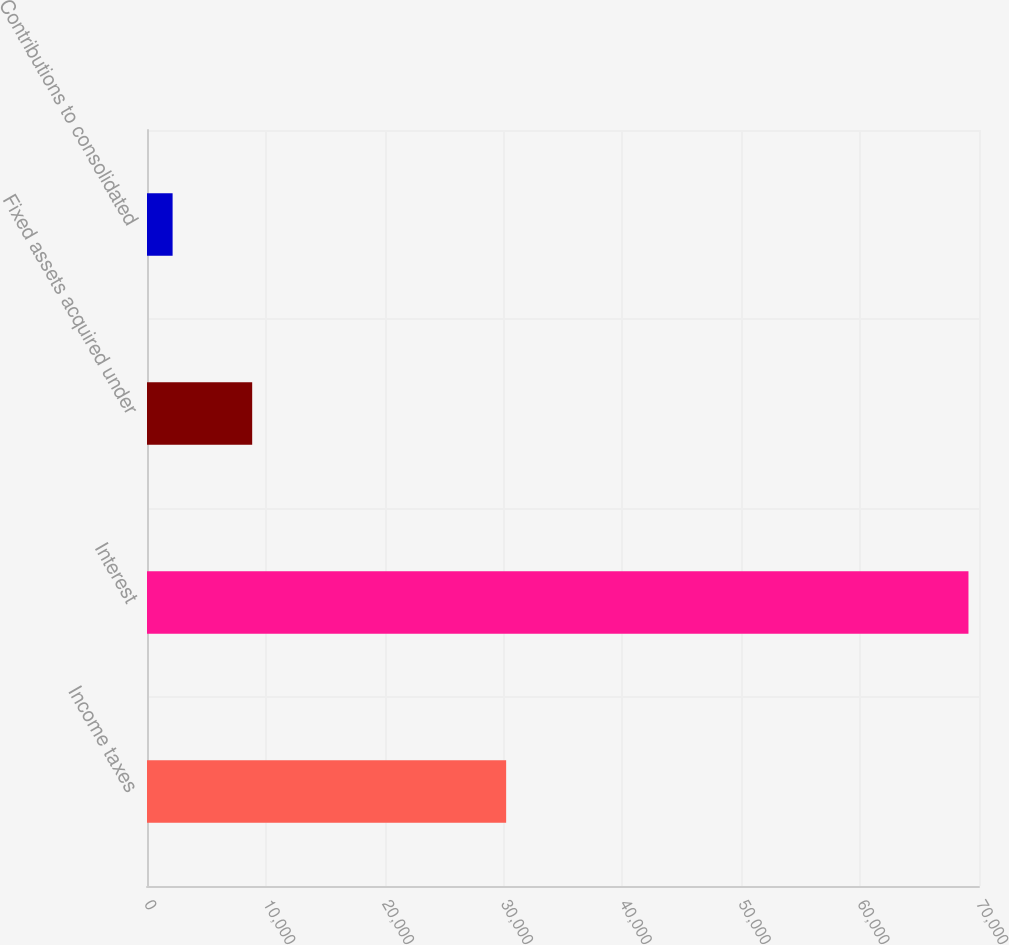<chart> <loc_0><loc_0><loc_500><loc_500><bar_chart><fcel>Income taxes<fcel>Interest<fcel>Fixed assets acquired under<fcel>Contributions to consolidated<nl><fcel>30217<fcel>69114<fcel>8850<fcel>2154<nl></chart> 